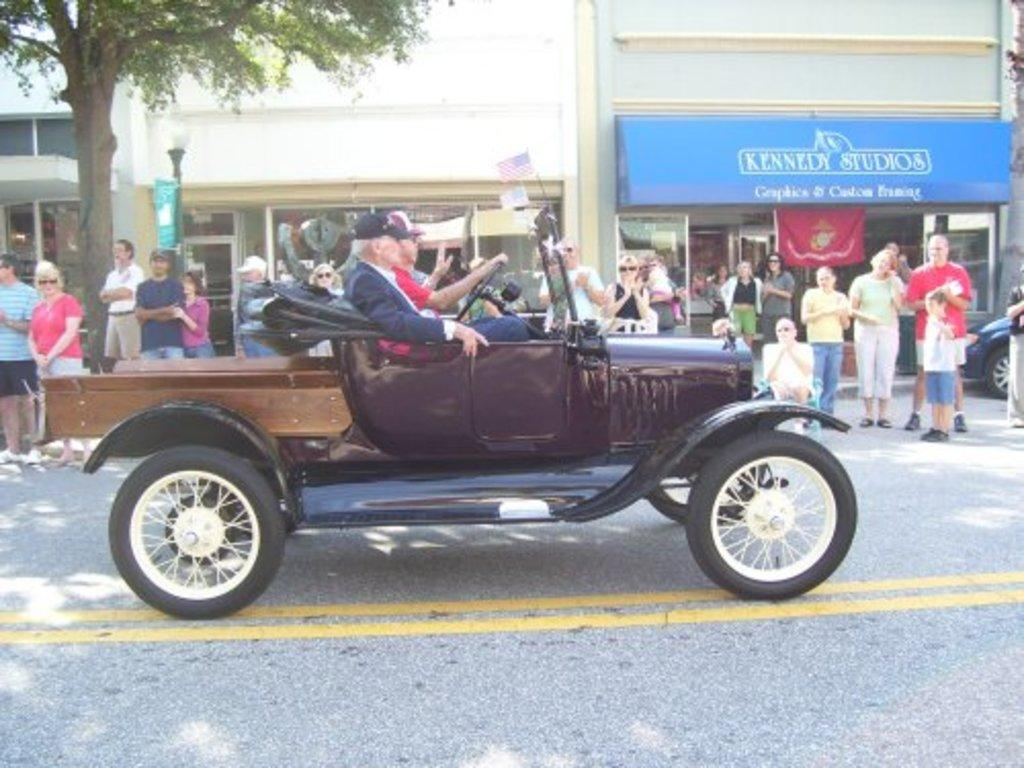How many people are in the image? There is a group of people in the image. Where are the people located in the image? The people are standing on a road. What are two persons doing in the image? Two persons are sitting on a jeep seat. What activity are they engaged in? They are riding a jeep. What can be seen in the background of the image? There are buildings and trees visible in the background of the image. What type of mark can be seen on the fog in the image? There is no fog or mark present in the image. What is the cart used for in the image? There is no cart present in the image. 